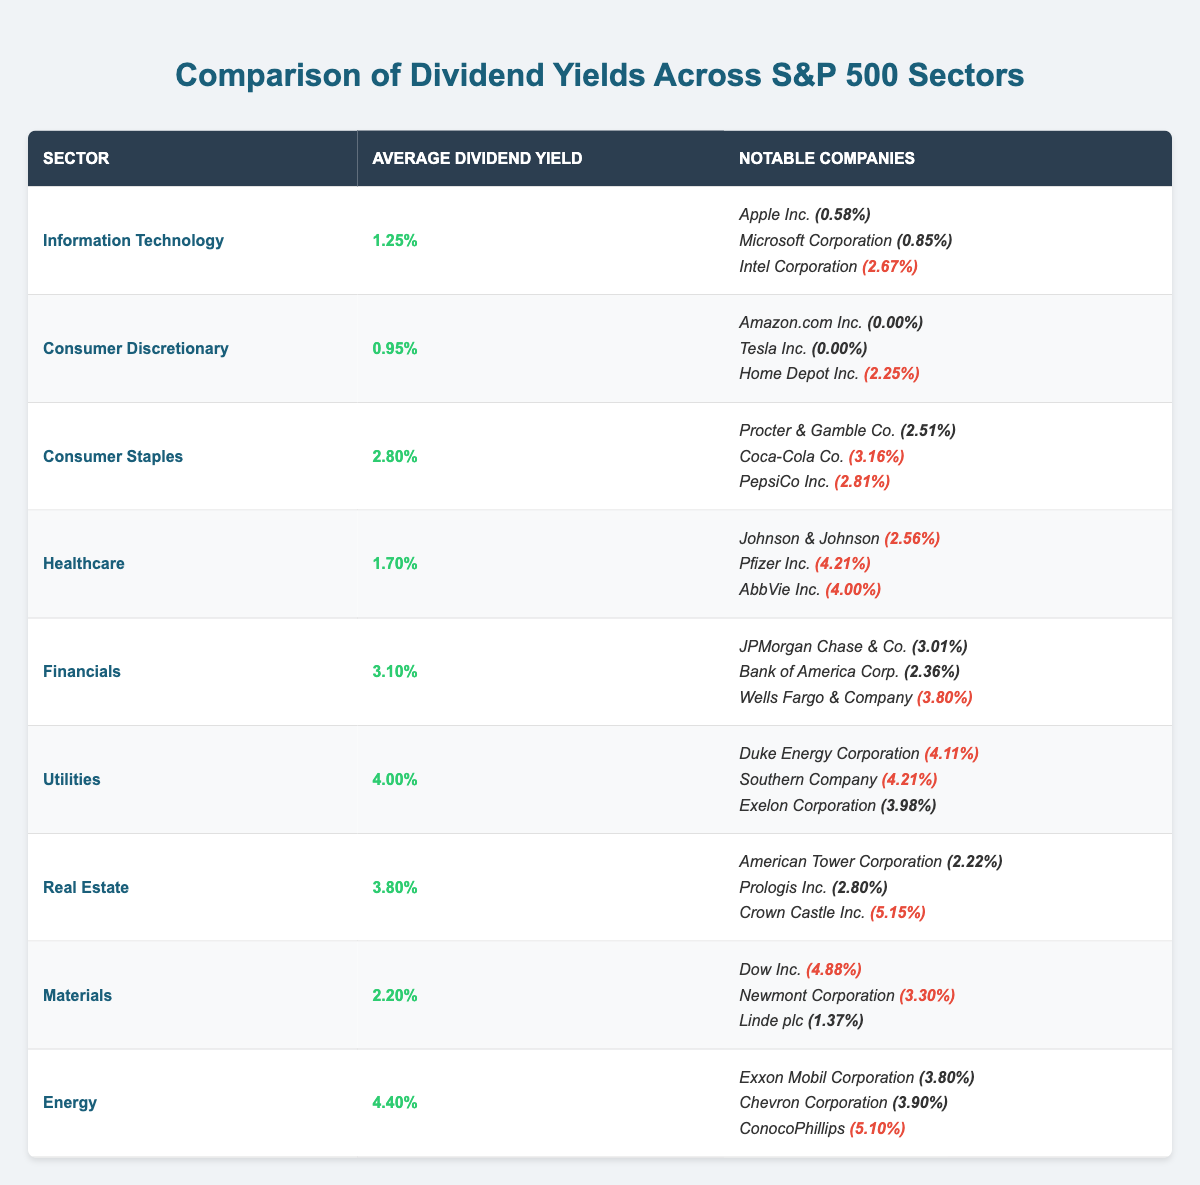What is the average dividend yield of the Utilities sector? The table indicates that the average dividend yield for the Utilities sector is specifically listed under its respective row. The value recorded is 4.00%.
Answer: 4.00% Which sector has the highest average dividend yield? By examining the average dividend yields provided for each sector, the Energy sector holds the highest average yield at 4.40%.
Answer: Energy What is the dividend yield of Coca-Cola Co.? The table lists Coca-Cola Co. under the Consumer Staples sector, where it shows a dividend yield of 3.16%.
Answer: 3.16% How many sectors have an average dividend yield above 3%? Observing the average yields, the sectors with yields above 3% are Financials (3.10%), Utilities (4.00%), Real Estate (3.80%), and Energy (4.40%). Thus, there are four such sectors.
Answer: 4 Which company in the Healthcare sector has the highest dividend yield? The Healthcare sector row details multiple companies and their yields. Among them, Pfizer Inc. has the highest yield at 4.21%.
Answer: Pfizer Inc. (4.21%) What is the difference between the average dividend yield of Consumer Staples and Consumer Discretionary? The average yield for Consumer Staples is 2.80% and for Consumer Discretionary is 0.95%. Therefore, the difference is calculated as follows: 2.80% - 0.95% = 1.85%.
Answer: 1.85% Is it true that all companies in the Consumer Discretionary sector have a positive dividend yield? In the Consumer Discretionary sector row, both Amazon.com Inc. and Tesla Inc. have yields of 0.00%, indicating they do not pay dividends. Thus, the statement is false.
Answer: False How does the average dividend yield of Financials compare to that of Information Technology? The Financials sector has an average yield of 3.10%, while Information Technology has an average yield of 1.25%. Therefore, Financials has a significantly higher average yield by 1.85%.
Answer: Financials is higher by 1.85% Which sector has the lowest average dividend yield? By analyzing the average yields provided, Consumer Discretionary shows the lowest average yield at 0.95%.
Answer: Consumer Discretionary Can you identify a company with a dividend yield exceeding 5%? The Real Estate sector lists Crown Castle Inc. with a yield of 5.15%, which is greater than 5%.
Answer: Crown Castle Inc. (5.15%) 